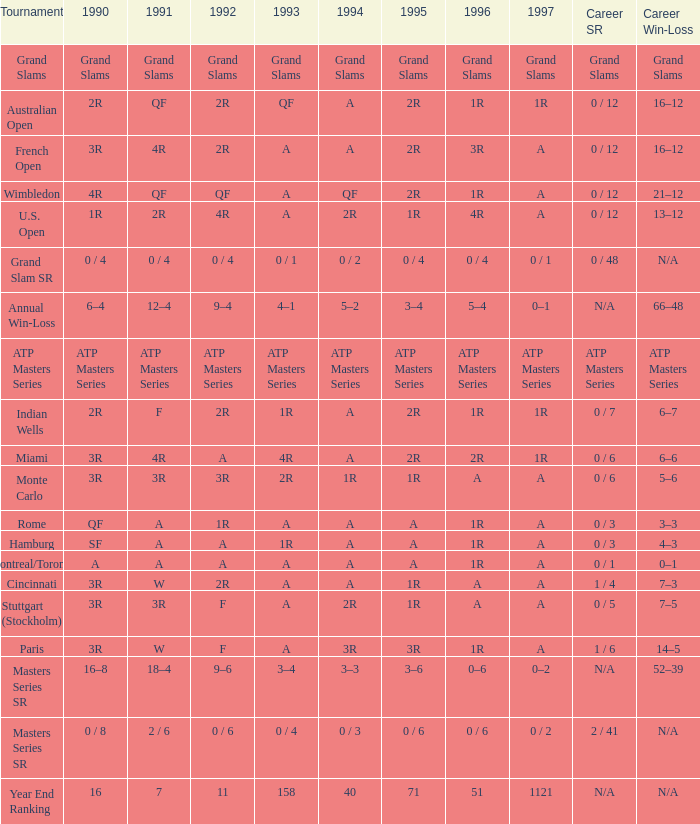Give me the full table as a dictionary. {'header': ['Tournament', '1990', '1991', '1992', '1993', '1994', '1995', '1996', '1997', 'Career SR', 'Career Win-Loss'], 'rows': [['Grand Slams', 'Grand Slams', 'Grand Slams', 'Grand Slams', 'Grand Slams', 'Grand Slams', 'Grand Slams', 'Grand Slams', 'Grand Slams', 'Grand Slams', 'Grand Slams'], ['Australian Open', '2R', 'QF', '2R', 'QF', 'A', '2R', '1R', '1R', '0 / 12', '16–12'], ['French Open', '3R', '4R', '2R', 'A', 'A', '2R', '3R', 'A', '0 / 12', '16–12'], ['Wimbledon', '4R', 'QF', 'QF', 'A', 'QF', '2R', '1R', 'A', '0 / 12', '21–12'], ['U.S. Open', '1R', '2R', '4R', 'A', '2R', '1R', '4R', 'A', '0 / 12', '13–12'], ['Grand Slam SR', '0 / 4', '0 / 4', '0 / 4', '0 / 1', '0 / 2', '0 / 4', '0 / 4', '0 / 1', '0 / 48', 'N/A'], ['Annual Win-Loss', '6–4', '12–4', '9–4', '4–1', '5–2', '3–4', '5–4', '0–1', 'N/A', '66–48'], ['ATP Masters Series', 'ATP Masters Series', 'ATP Masters Series', 'ATP Masters Series', 'ATP Masters Series', 'ATP Masters Series', 'ATP Masters Series', 'ATP Masters Series', 'ATP Masters Series', 'ATP Masters Series', 'ATP Masters Series'], ['Indian Wells', '2R', 'F', '2R', '1R', 'A', '2R', '1R', '1R', '0 / 7', '6–7'], ['Miami', '3R', '4R', 'A', '4R', 'A', '2R', '2R', '1R', '0 / 6', '6–6'], ['Monte Carlo', '3R', '3R', '3R', '2R', '1R', '1R', 'A', 'A', '0 / 6', '5–6'], ['Rome', 'QF', 'A', '1R', 'A', 'A', 'A', '1R', 'A', '0 / 3', '3–3'], ['Hamburg', 'SF', 'A', 'A', '1R', 'A', 'A', '1R', 'A', '0 / 3', '4–3'], ['Montreal/Toronto', 'A', 'A', 'A', 'A', 'A', 'A', '1R', 'A', '0 / 1', '0–1'], ['Cincinnati', '3R', 'W', '2R', 'A', 'A', '1R', 'A', 'A', '1 / 4', '7–3'], ['Stuttgart (Stockholm)', '3R', '3R', 'F', 'A', '2R', '1R', 'A', 'A', '0 / 5', '7–5'], ['Paris', '3R', 'W', 'F', 'A', '3R', '3R', '1R', 'A', '1 / 6', '14–5'], ['Masters Series SR', '16–8', '18–4', '9–6', '3–4', '3–3', '3–6', '0–6', '0–2', 'N/A', '52–39'], ['Masters Series SR', '0 / 8', '2 / 6', '0 / 6', '0 / 4', '0 / 3', '0 / 6', '0 / 6', '0 / 2', '2 / 41', 'N/A'], ['Year End Ranking', '16', '7', '11', '158', '40', '71', '51', '1121', 'N/A', 'N/A']]} What is the championship when the professional achievement rate is "atp masters series"? ATP Masters Series. 